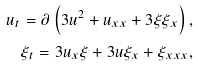Convert formula to latex. <formula><loc_0><loc_0><loc_500><loc_500>u _ { t } = \partial \left ( 3 u ^ { 2 } + u _ { x x } + 3 \xi \xi _ { x } \right ) , \\ \xi _ { t } = 3 u _ { x } \xi + 3 u \xi _ { x } + \xi _ { x x x } ,</formula> 